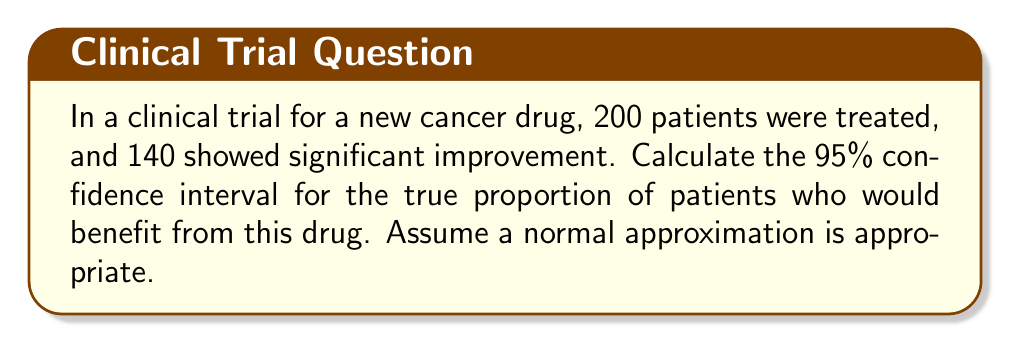Show me your answer to this math problem. Let's approach this step-by-step:

1) First, we calculate the sample proportion $\hat{p}$:
   $$\hat{p} = \frac{140}{200} = 0.7$$

2) The formula for the confidence interval is:
   $$\hat{p} \pm z_{\alpha/2} \sqrt{\frac{\hat{p}(1-\hat{p})}{n}}$$
   where $z_{\alpha/2}$ is the critical value for the desired confidence level.

3) For a 95% confidence interval, $z_{\alpha/2} = 1.96$

4) We can now substitute our values:
   $$0.7 \pm 1.96 \sqrt{\frac{0.7(1-0.7)}{200}}$$

5) Simplify under the square root:
   $$0.7 \pm 1.96 \sqrt{\frac{0.7(0.3)}{200}}$$
   $$0.7 \pm 1.96 \sqrt{\frac{0.21}{200}}$$
   $$0.7 \pm 1.96 \sqrt{0.00105}$$
   $$0.7 \pm 1.96 (0.0324)$$

6) Calculate the margin of error:
   $$1.96 (0.0324) = 0.0635$$

7) Therefore, the confidence interval is:
   $$0.7 \pm 0.0635$$
   $$(0.6365, 0.7635)$$

This means we can be 95% confident that the true proportion of patients who would benefit from this drug is between 63.65% and 76.35%.
Answer: (0.6365, 0.7635) 